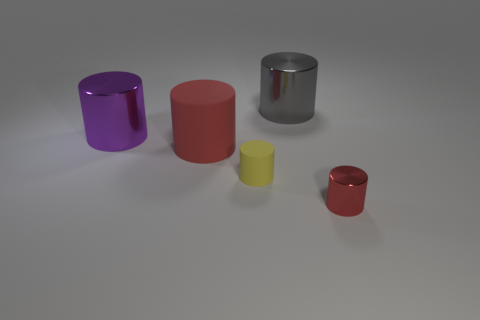What number of gray shiny things have the same size as the purple object?
Make the answer very short. 1. Is the tiny thing that is left of the gray object made of the same material as the gray cylinder?
Offer a terse response. No. Is the number of tiny shiny objects behind the large purple cylinder less than the number of green metallic cylinders?
Provide a short and direct response. No. There is a purple metallic object that is the same size as the red rubber cylinder; what is its shape?
Provide a succinct answer. Cylinder. Is there a yellow rubber object of the same shape as the large red thing?
Provide a succinct answer. Yes. Does the large metallic thing in front of the big gray cylinder have the same shape as the metallic thing behind the large purple metallic object?
Give a very brief answer. Yes. There is a gray thing that is the same size as the purple thing; what is it made of?
Your answer should be very brief. Metal. What number of other objects are the same material as the gray cylinder?
Make the answer very short. 2. What number of objects are either tiny yellow cylinders or large objects behind the big red object?
Provide a short and direct response. 3. How many other objects are the same color as the small rubber cylinder?
Provide a short and direct response. 0. 